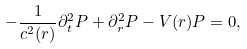<formula> <loc_0><loc_0><loc_500><loc_500>- \frac { 1 } { c ^ { 2 } ( r ) } \partial _ { t } ^ { 2 } P + \partial _ { r } ^ { 2 } P - V ( r ) P = 0 ,</formula> 